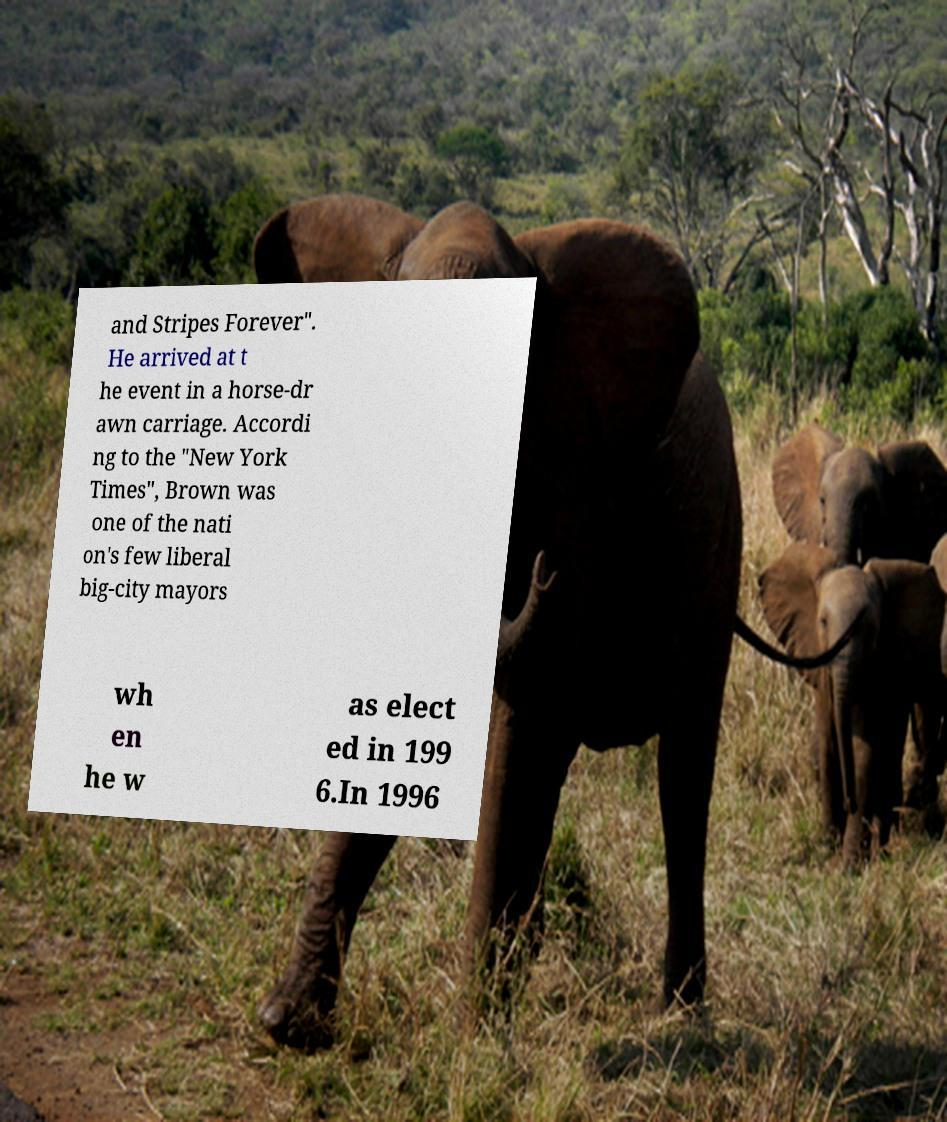There's text embedded in this image that I need extracted. Can you transcribe it verbatim? and Stripes Forever". He arrived at t he event in a horse-dr awn carriage. Accordi ng to the "New York Times", Brown was one of the nati on's few liberal big-city mayors wh en he w as elect ed in 199 6.In 1996 